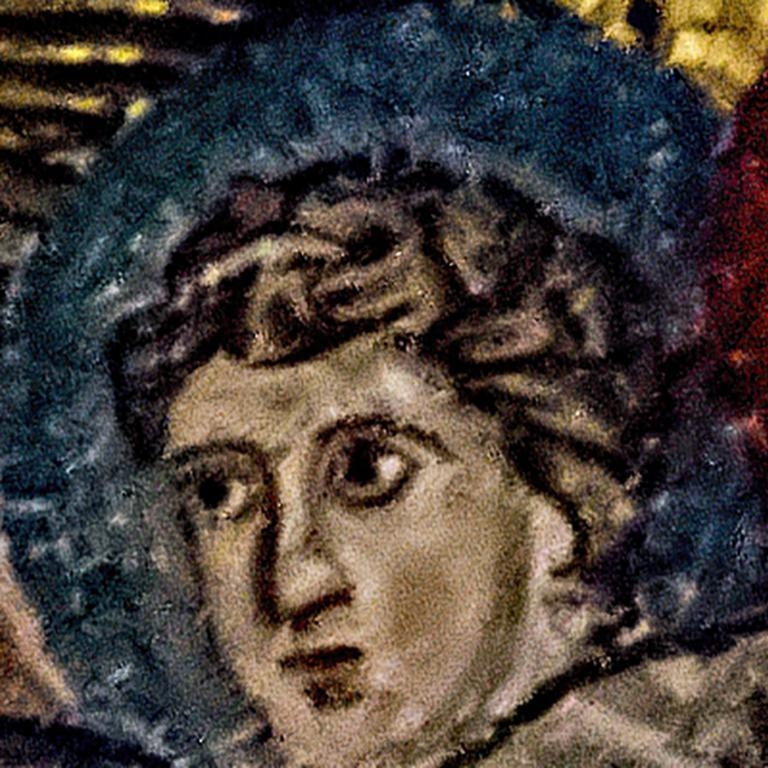What is the main subject of the image? There is a painting in the image. How many dolls are present in the painting? There is no information about dolls in the provided fact, and therefore we cannot determine their presence in the painting. 